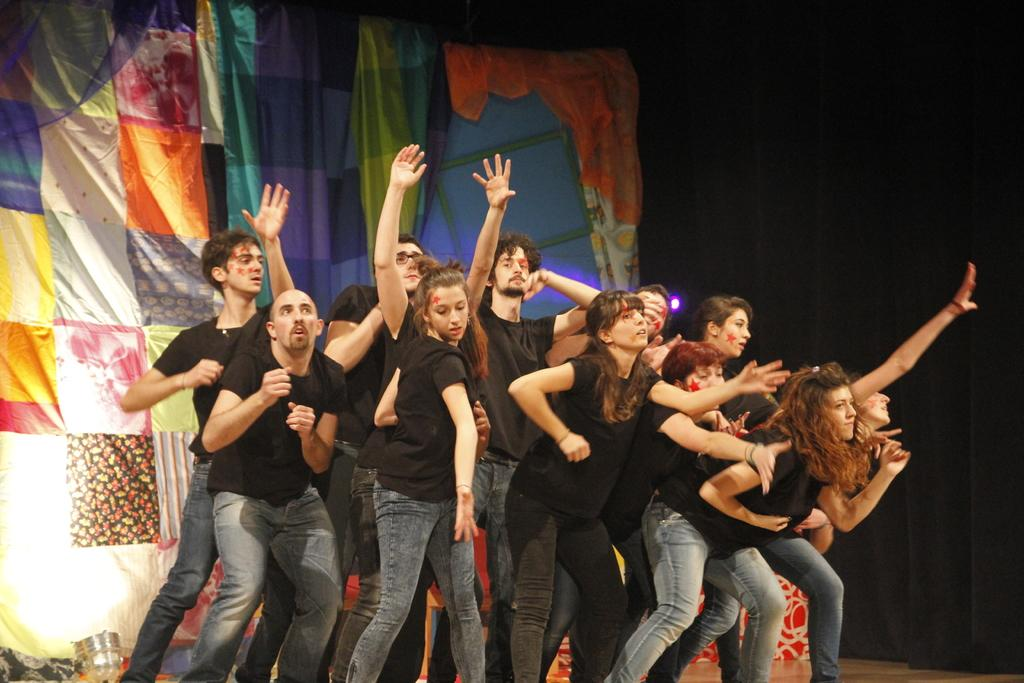Who or what can be seen in the image? People are present in the image. What are the people wearing? The people are wearing black t-shirts and jeans. What can be observed about the background of the image? There is a colorful background in the image, and a black background on the right side. What type of pollution is visible in the image? There is no pollution visible in the image; it features people wearing black t-shirts and jeans against a colorful background. What is the source of the surprise in the image? There is no surprise or any indication of surprise in the image. 